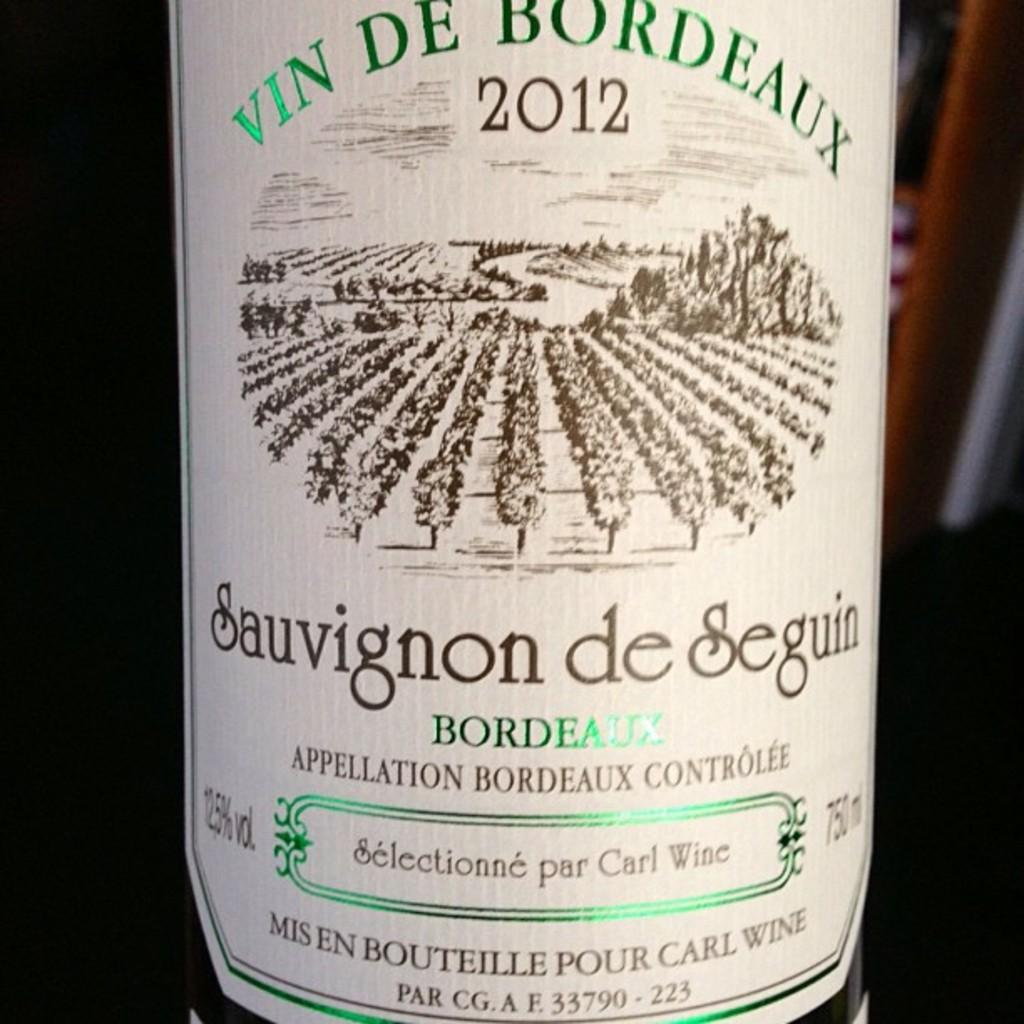<image>
Write a terse but informative summary of the picture. the year 2012 is on the beer bottle 